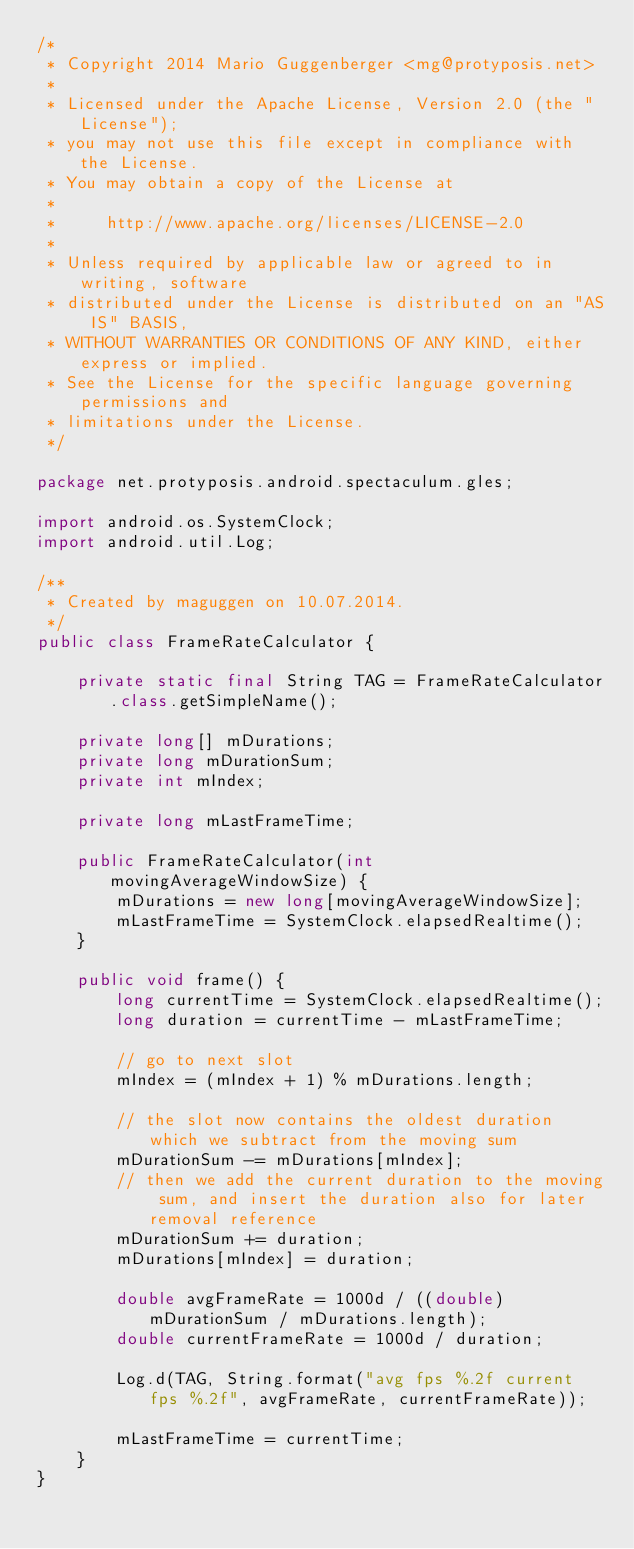<code> <loc_0><loc_0><loc_500><loc_500><_Java_>/*
 * Copyright 2014 Mario Guggenberger <mg@protyposis.net>
 *
 * Licensed under the Apache License, Version 2.0 (the "License");
 * you may not use this file except in compliance with the License.
 * You may obtain a copy of the License at
 *
 *     http://www.apache.org/licenses/LICENSE-2.0
 *
 * Unless required by applicable law or agreed to in writing, software
 * distributed under the License is distributed on an "AS IS" BASIS,
 * WITHOUT WARRANTIES OR CONDITIONS OF ANY KIND, either express or implied.
 * See the License for the specific language governing permissions and
 * limitations under the License.
 */

package net.protyposis.android.spectaculum.gles;

import android.os.SystemClock;
import android.util.Log;

/**
 * Created by maguggen on 10.07.2014.
 */
public class FrameRateCalculator {

    private static final String TAG = FrameRateCalculator.class.getSimpleName();

    private long[] mDurations;
    private long mDurationSum;
    private int mIndex;

    private long mLastFrameTime;

    public FrameRateCalculator(int movingAverageWindowSize) {
        mDurations = new long[movingAverageWindowSize];
        mLastFrameTime = SystemClock.elapsedRealtime();
    }

    public void frame() {
        long currentTime = SystemClock.elapsedRealtime();
        long duration = currentTime - mLastFrameTime;

        // go to next slot
        mIndex = (mIndex + 1) % mDurations.length;

        // the slot now contains the oldest duration which we subtract from the moving sum
        mDurationSum -= mDurations[mIndex];
        // then we add the current duration to the moving sum, and insert the duration also for later removal reference
        mDurationSum += duration;
        mDurations[mIndex] = duration;

        double avgFrameRate = 1000d / ((double) mDurationSum / mDurations.length);
        double currentFrameRate = 1000d / duration;

        Log.d(TAG, String.format("avg fps %.2f current fps %.2f", avgFrameRate, currentFrameRate));

        mLastFrameTime = currentTime;
    }
}
</code> 